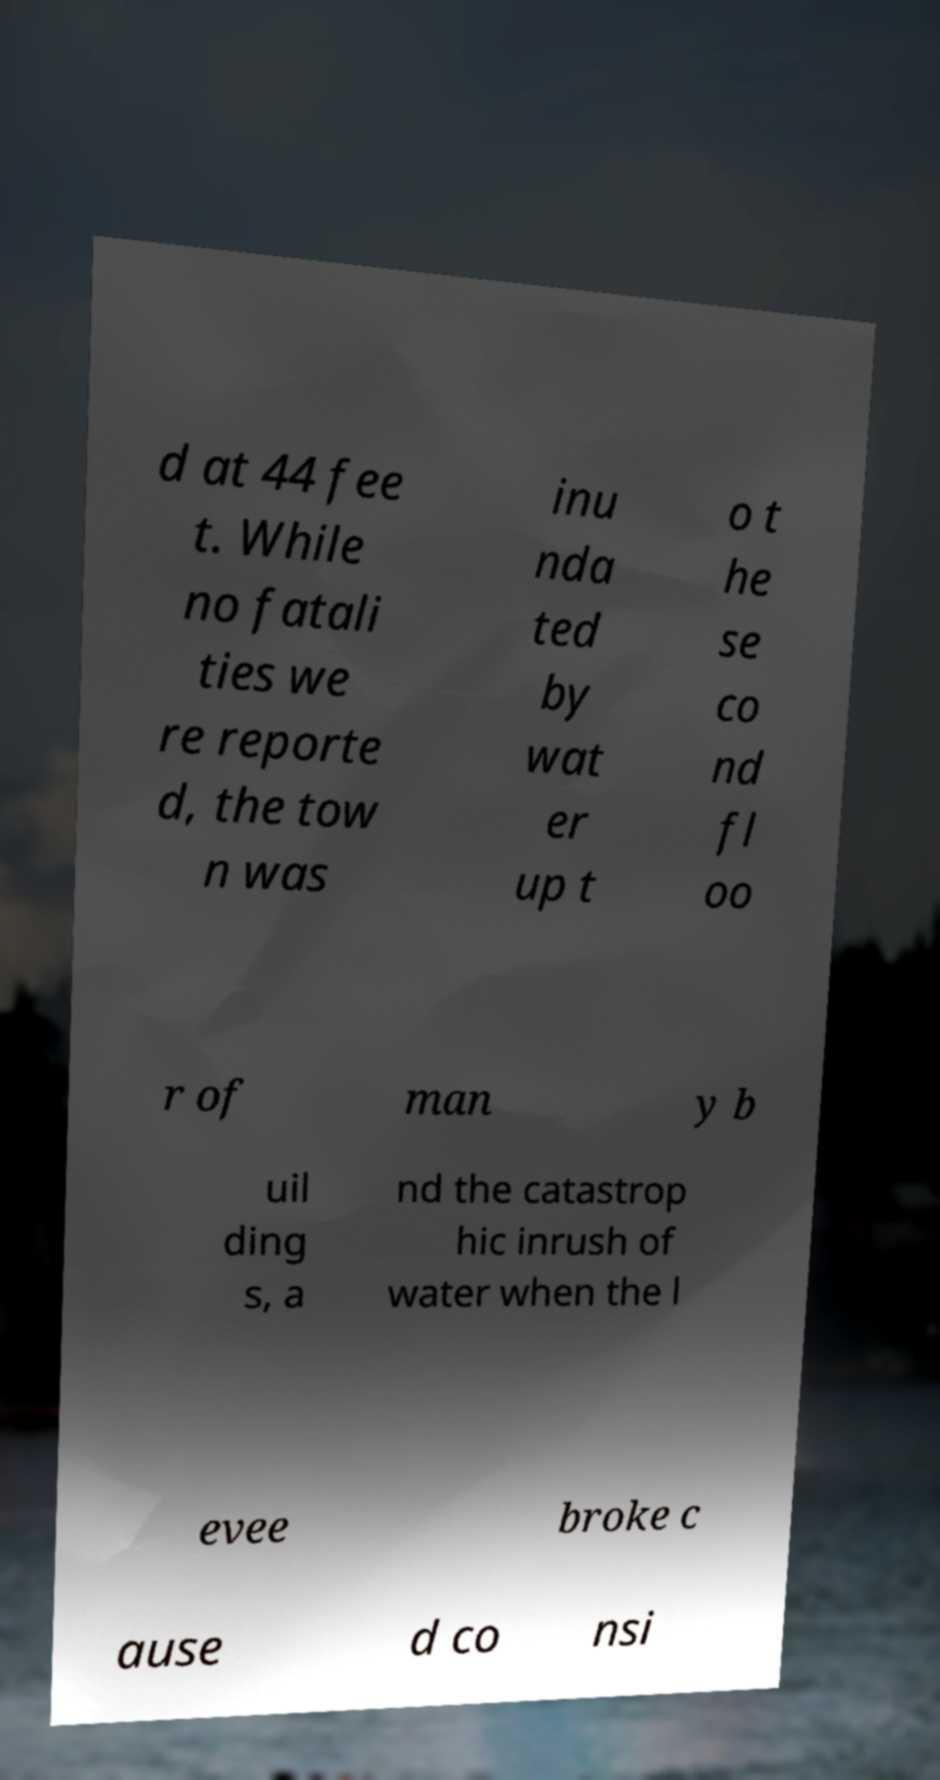Please identify and transcribe the text found in this image. d at 44 fee t. While no fatali ties we re reporte d, the tow n was inu nda ted by wat er up t o t he se co nd fl oo r of man y b uil ding s, a nd the catastrop hic inrush of water when the l evee broke c ause d co nsi 